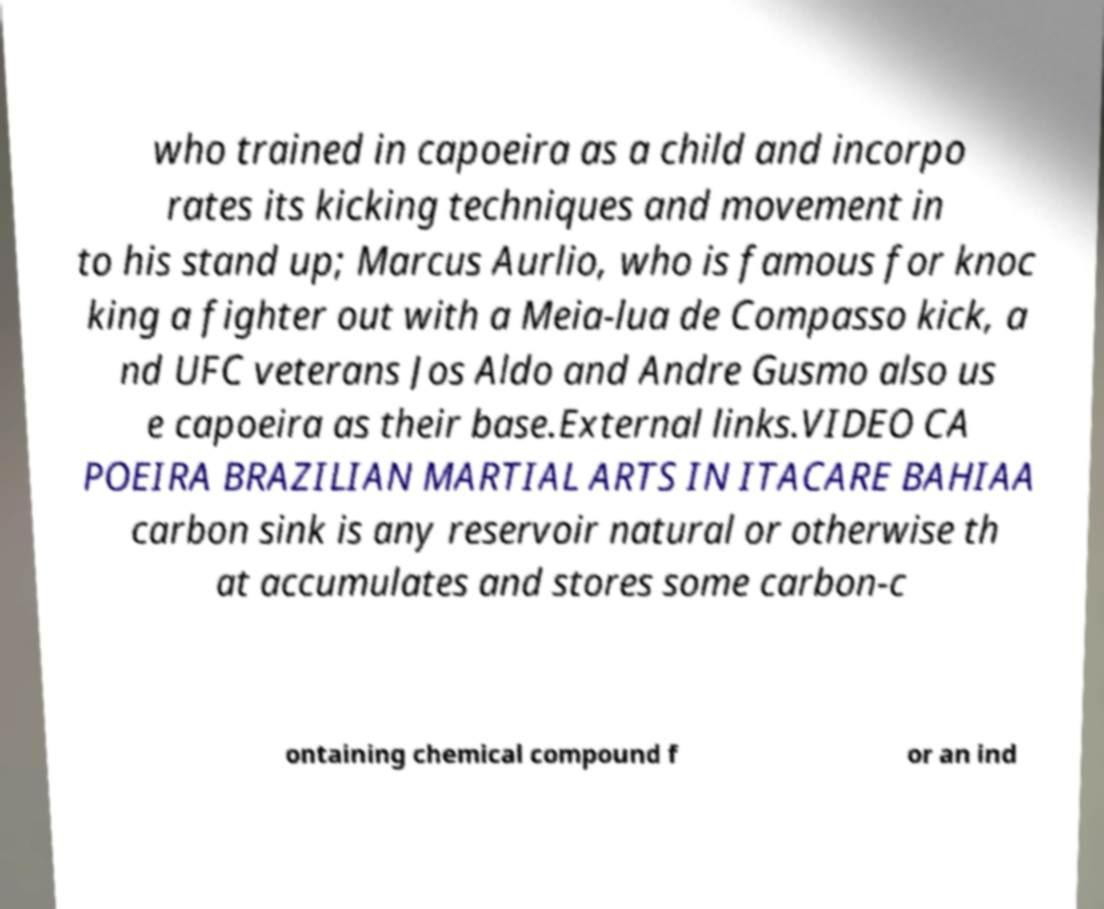What messages or text are displayed in this image? I need them in a readable, typed format. who trained in capoeira as a child and incorpo rates its kicking techniques and movement in to his stand up; Marcus Aurlio, who is famous for knoc king a fighter out with a Meia-lua de Compasso kick, a nd UFC veterans Jos Aldo and Andre Gusmo also us e capoeira as their base.External links.VIDEO CA POEIRA BRAZILIAN MARTIAL ARTS IN ITACARE BAHIAA carbon sink is any reservoir natural or otherwise th at accumulates and stores some carbon-c ontaining chemical compound f or an ind 